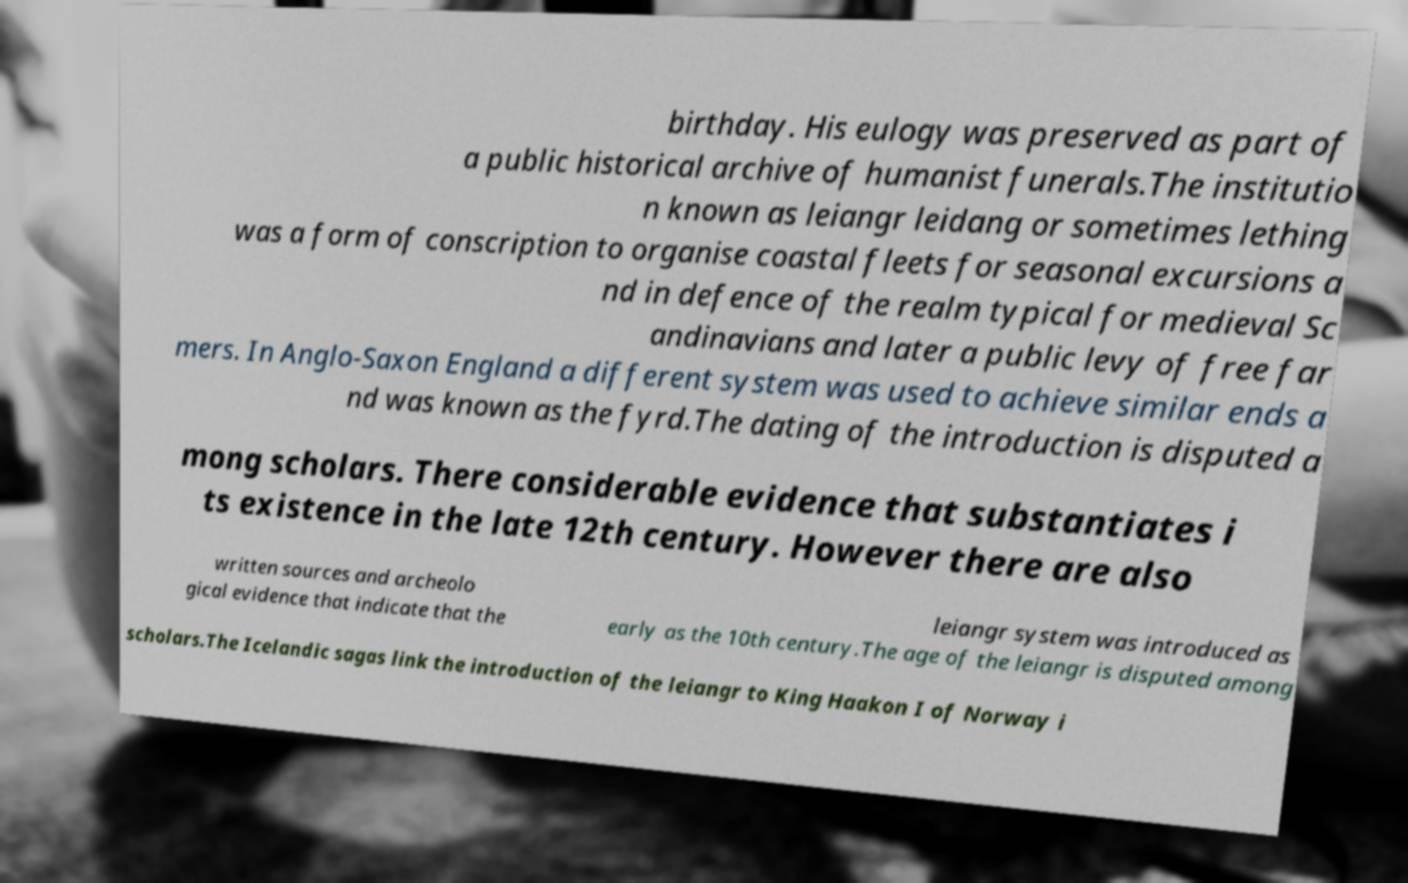Please identify and transcribe the text found in this image. birthday. His eulogy was preserved as part of a public historical archive of humanist funerals.The institutio n known as leiangr leidang or sometimes lething was a form of conscription to organise coastal fleets for seasonal excursions a nd in defence of the realm typical for medieval Sc andinavians and later a public levy of free far mers. In Anglo-Saxon England a different system was used to achieve similar ends a nd was known as the fyrd.The dating of the introduction is disputed a mong scholars. There considerable evidence that substantiates i ts existence in the late 12th century. However there are also written sources and archeolo gical evidence that indicate that the leiangr system was introduced as early as the 10th century.The age of the leiangr is disputed among scholars.The Icelandic sagas link the introduction of the leiangr to King Haakon I of Norway i 